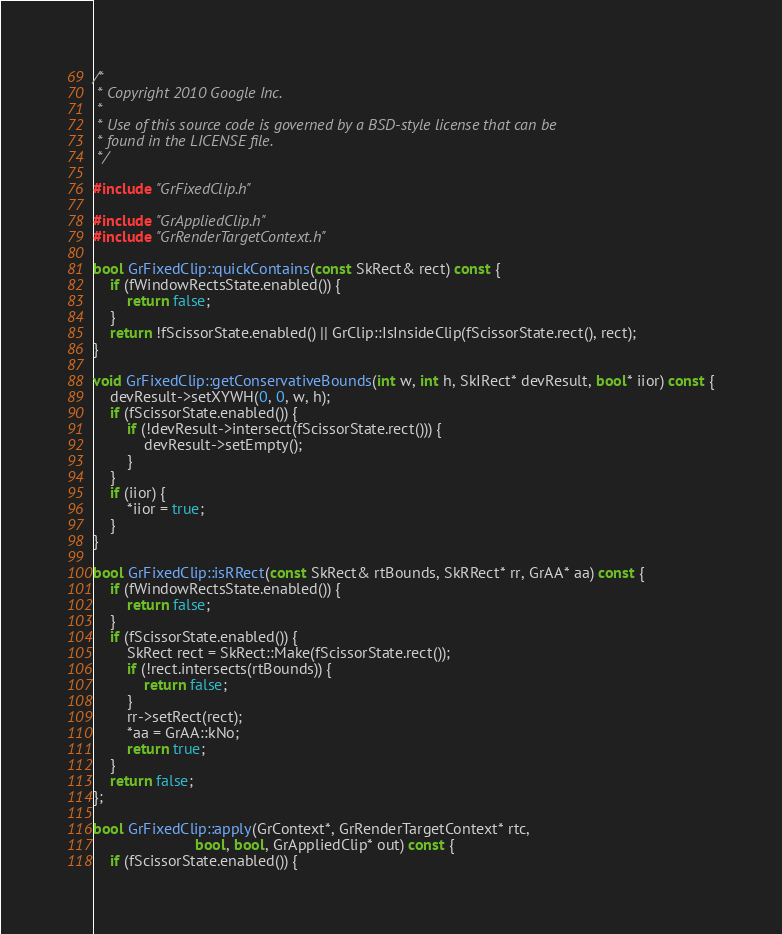<code> <loc_0><loc_0><loc_500><loc_500><_C++_>/*
 * Copyright 2010 Google Inc.
 *
 * Use of this source code is governed by a BSD-style license that can be
 * found in the LICENSE file.
 */

#include "GrFixedClip.h"

#include "GrAppliedClip.h"
#include "GrRenderTargetContext.h"

bool GrFixedClip::quickContains(const SkRect& rect) const {
    if (fWindowRectsState.enabled()) {
        return false;
    }
    return !fScissorState.enabled() || GrClip::IsInsideClip(fScissorState.rect(), rect);
}

void GrFixedClip::getConservativeBounds(int w, int h, SkIRect* devResult, bool* iior) const {
    devResult->setXYWH(0, 0, w, h);
    if (fScissorState.enabled()) {
        if (!devResult->intersect(fScissorState.rect())) {
            devResult->setEmpty();
        }
    }
    if (iior) {
        *iior = true;
    }
}

bool GrFixedClip::isRRect(const SkRect& rtBounds, SkRRect* rr, GrAA* aa) const {
    if (fWindowRectsState.enabled()) {
        return false;
    }
    if (fScissorState.enabled()) {
        SkRect rect = SkRect::Make(fScissorState.rect());
        if (!rect.intersects(rtBounds)) {
            return false;
        }
        rr->setRect(rect);
        *aa = GrAA::kNo;
        return true;
    }
    return false;
};

bool GrFixedClip::apply(GrContext*, GrRenderTargetContext* rtc,
                        bool, bool, GrAppliedClip* out) const {
    if (fScissorState.enabled()) {</code> 